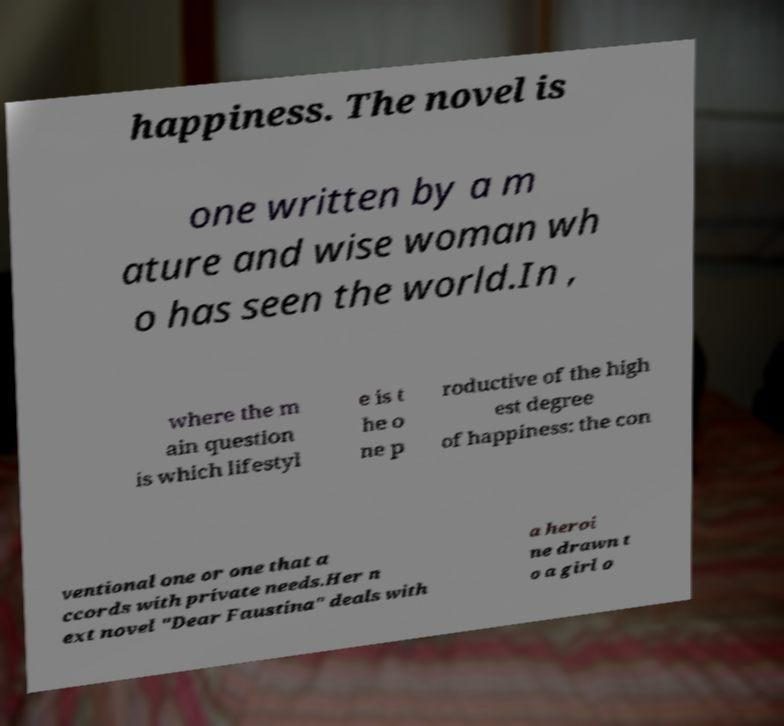For documentation purposes, I need the text within this image transcribed. Could you provide that? happiness. The novel is one written by a m ature and wise woman wh o has seen the world.In , where the m ain question is which lifestyl e is t he o ne p roductive of the high est degree of happiness: the con ventional one or one that a ccords with private needs.Her n ext novel "Dear Faustina" deals with a heroi ne drawn t o a girl o 